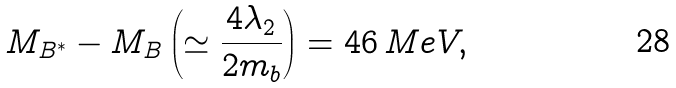<formula> <loc_0><loc_0><loc_500><loc_500>M _ { B ^ { * } } - M _ { B } \left ( \simeq \frac { 4 \lambda _ { 2 } } { 2 m _ { b } } \right ) = 4 6 \, M e V ,</formula> 